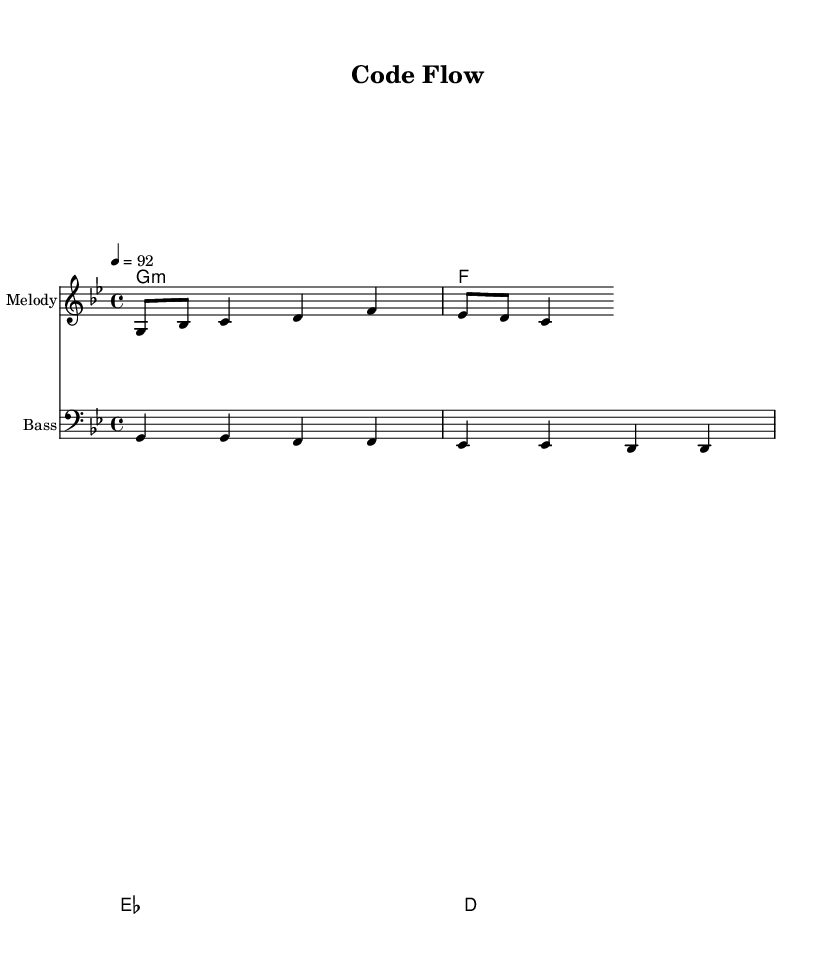What is the key signature of this music? The key signature is G minor, which typically has two flats (B flat and E flat). This can be identified by examining the key signature at the beginning of the sheet music.
Answer: G minor What is the time signature of this music? The time signature is 4/4, indicated after the key signature at the start of the sheet music. This means there are four beats in each measure and the quarter note gets one beat.
Answer: 4/4 What is the tempo marking of this music? The tempo marking is 92 beats per minute, as stated at the beginning of the score. This indicates how fast the music should be played.
Answer: 92 What instrument is indicated for the melody? The instrument for the melody is designated in the staff markings. It is shown as "Melody," indicating this staff is intended for the melody line.
Answer: Melody How many measures are there in the main melody? By counting the distinct groupings of notes, we find that the main melody consists of six measures. Each measure is delineated by vertical lines.
Answer: Six What is the main theme of the lyrics? The lyrics mention coding and front-end design, indicating that the theme revolves around creating visually appealing web designs, typical of a tech-inspired hip-hop track.
Answer: Front-end design Which chord is played at the beginning of the music? The first chord indicated in the chord names is G minor, which can be seen in the chord mode section at the beginning of the score. This establishes the tonality for the piece.
Answer: G minor 